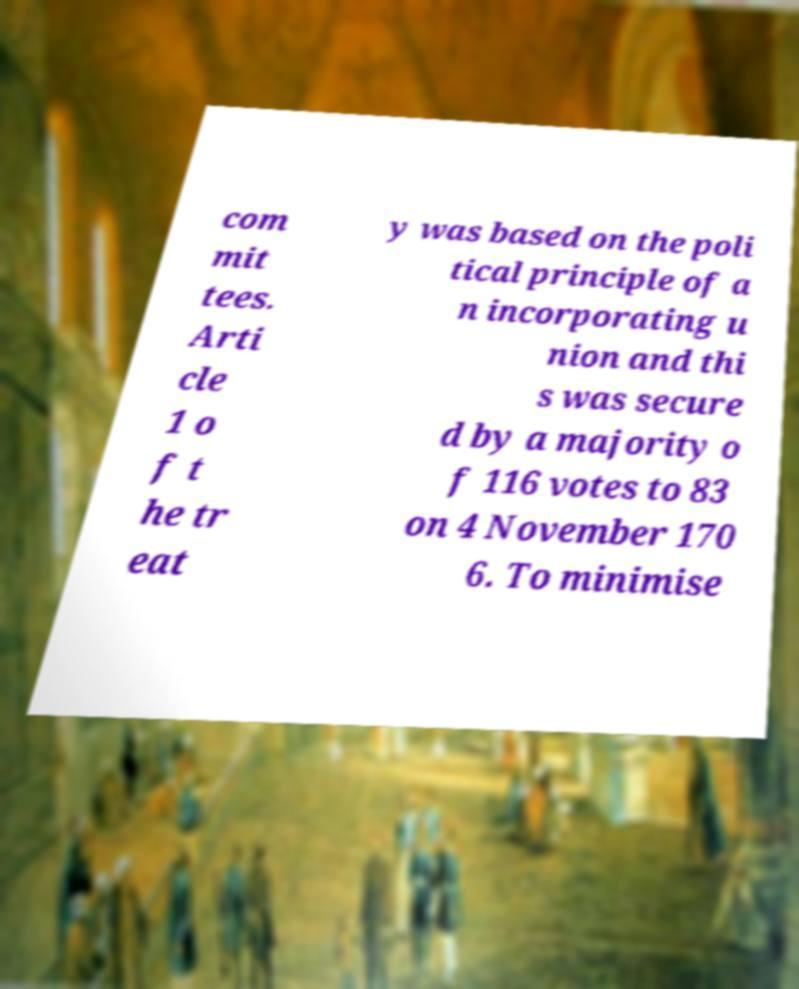Please identify and transcribe the text found in this image. com mit tees. Arti cle 1 o f t he tr eat y was based on the poli tical principle of a n incorporating u nion and thi s was secure d by a majority o f 116 votes to 83 on 4 November 170 6. To minimise 